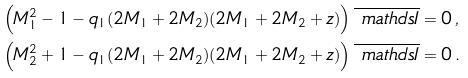Convert formula to latex. <formula><loc_0><loc_0><loc_500><loc_500>& \left ( M _ { 1 } ^ { 2 } - 1 - q _ { 1 } ( 2 M _ { 1 } + 2 M _ { 2 } ) ( 2 M _ { 1 } + 2 M _ { 2 } + z ) \right ) \overline { \ m a t h d s { I } } = 0 \, , \\ & \left ( M _ { 2 } ^ { 2 } + 1 - q _ { 1 } ( 2 M _ { 1 } + 2 M _ { 2 } ) ( 2 M _ { 1 } + 2 M _ { 2 } + z ) \right ) \overline { \ m a t h d s { I } } = 0 \, .</formula> 